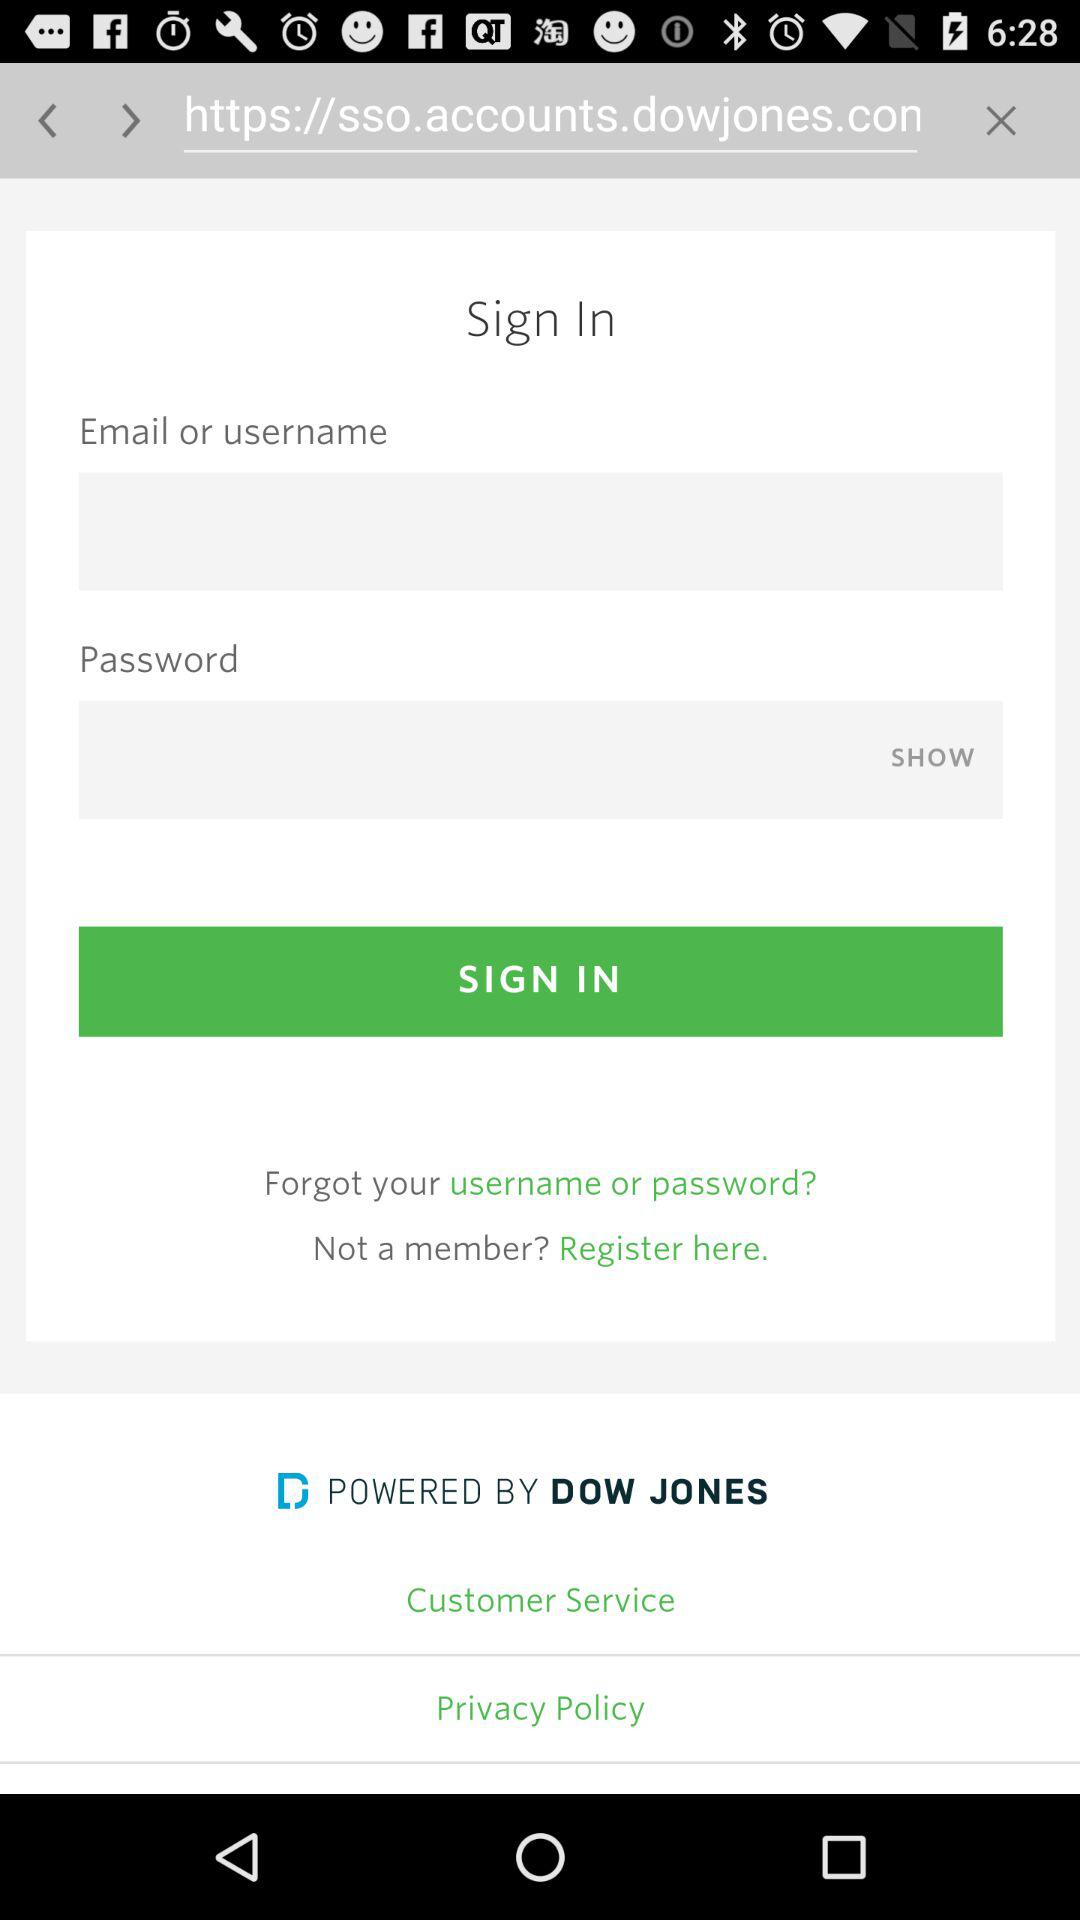What are the requirements to sign in? The requirements are "Email or username" and "Password". 